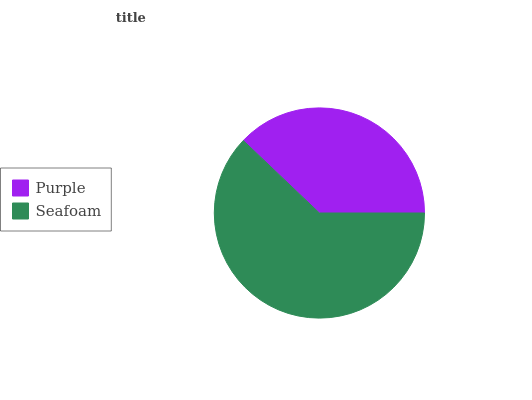Is Purple the minimum?
Answer yes or no. Yes. Is Seafoam the maximum?
Answer yes or no. Yes. Is Seafoam the minimum?
Answer yes or no. No. Is Seafoam greater than Purple?
Answer yes or no. Yes. Is Purple less than Seafoam?
Answer yes or no. Yes. Is Purple greater than Seafoam?
Answer yes or no. No. Is Seafoam less than Purple?
Answer yes or no. No. Is Seafoam the high median?
Answer yes or no. Yes. Is Purple the low median?
Answer yes or no. Yes. Is Purple the high median?
Answer yes or no. No. Is Seafoam the low median?
Answer yes or no. No. 